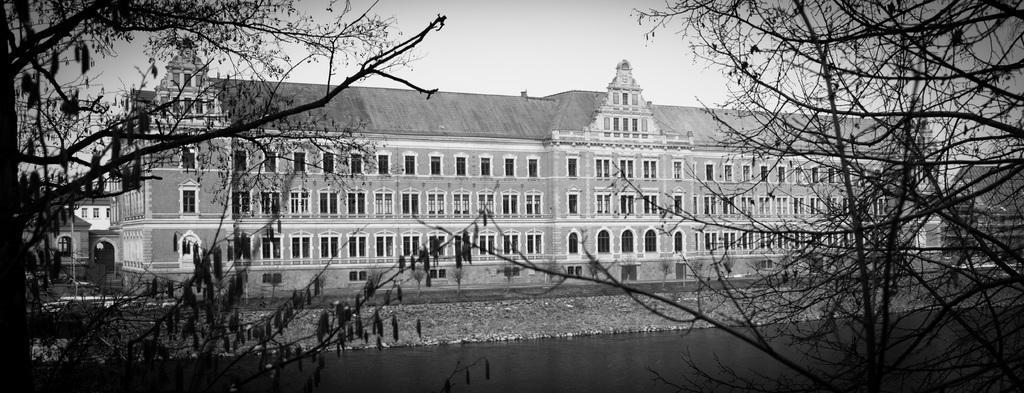Could you give a brief overview of what you see in this image? In this image there is building in front of that there is lake and trees. 